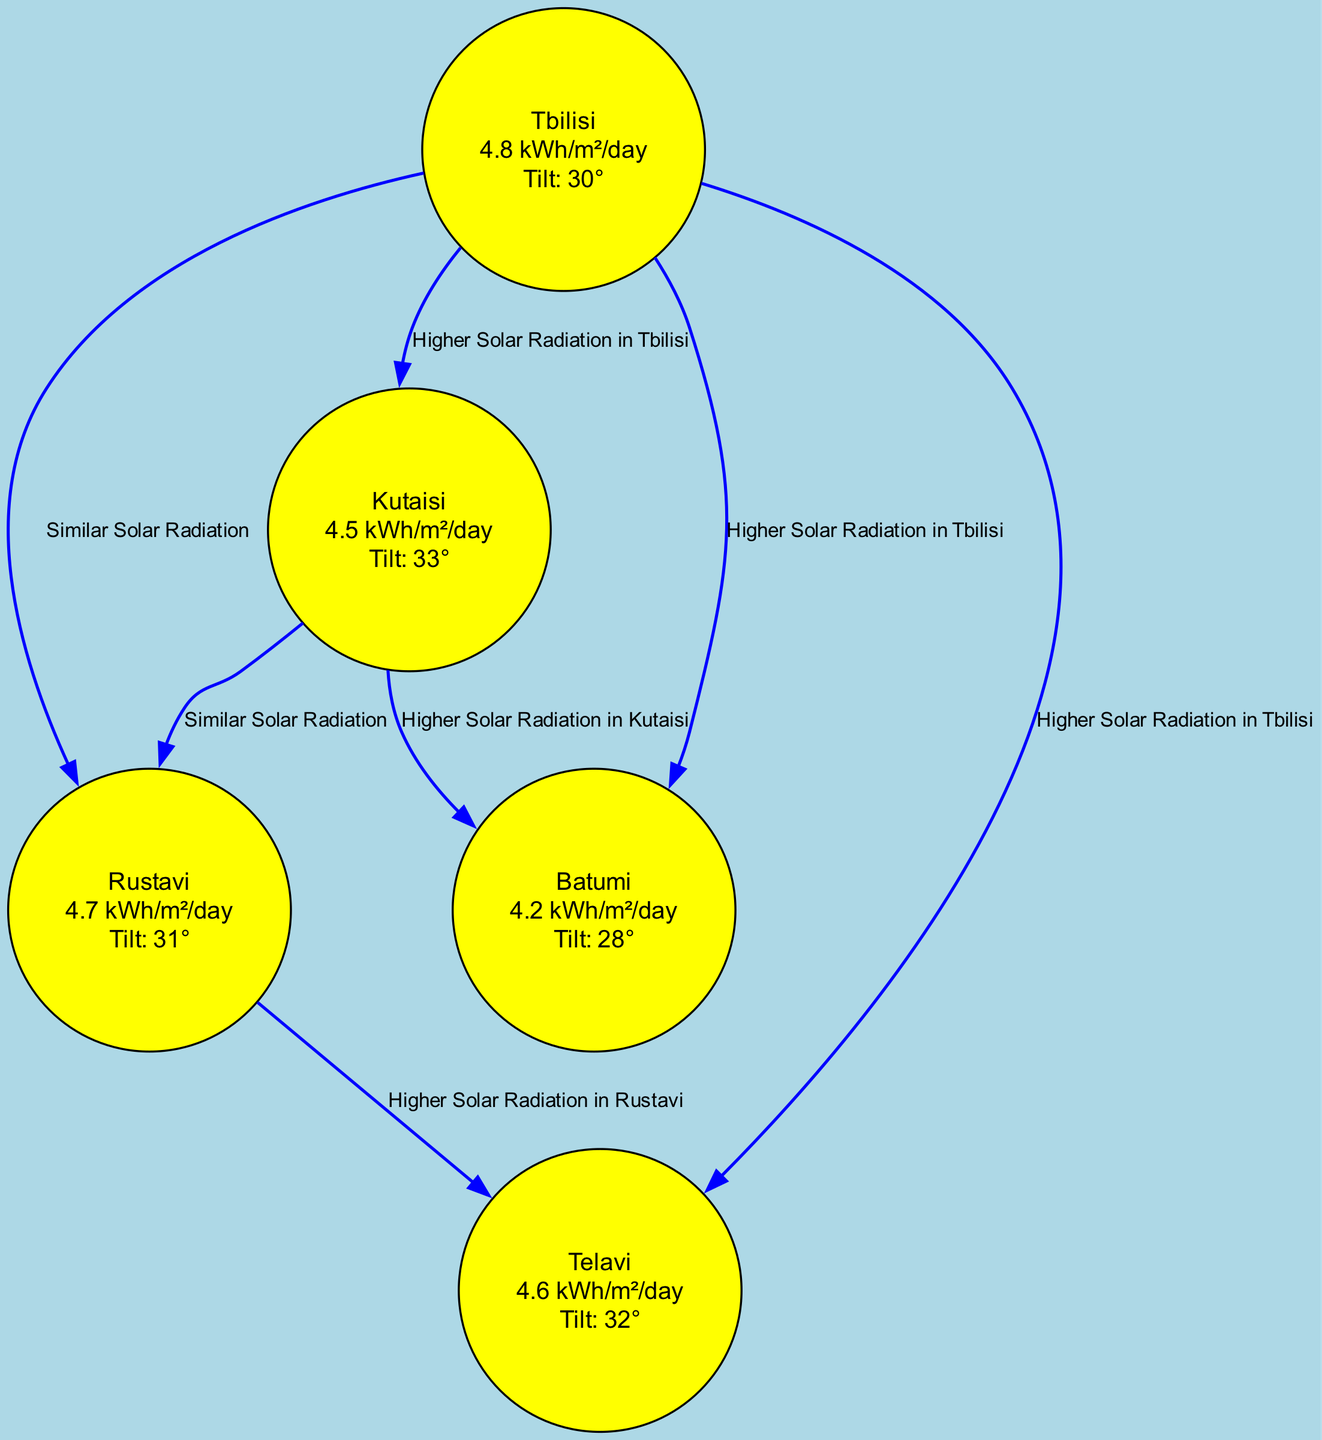What is the average solar radiation in Tbilisi? The diagram shows that Tbilisi has an average solar radiation value listed as "4.8 kWh/m²/day." This information is contained within the node for Tbilisi.
Answer: 4.8 kWh/m²/day What is the optimal tilt angle for solar panels in Batumi? The node for Batumi indicates that the optimal tilt angle is "28°." This detail is specifically provided under Batumi's information in the diagram.
Answer: 28° Which location has higher solar radiation, Tbilisi or Kutaisi? The diagram features an edge labeled "Higher Solar Radiation in Tbilisi" pointing from Tbilisi to Kutaisi. This signifies that Tbilisi has more solar radiation compared to Kutaisi.
Answer: Tbilisi How many nodes are represented in the diagram? The diagram lists five distinct locations (nodes): Tbilisi, Kutaisi, Batumi, Rustavi, and Telavi. Counting these nodes yields a total of five.
Answer: 5 What is the average solar radiation in Rustavi? The node for Rustavi displays an average solar radiation of "4.7 kWh/m²/day," which is clearly stated in its details.
Answer: 4.7 kWh/m²/day Which city has the lowest average solar radiation? By comparing average solar radiation values from all nodes, Batumi has the lowest value of "4.2 kWh/m²/day," making it the city with the least solar radiation in the diagram.
Answer: Batumi How do Tbilisi and Rustavi compare in solar radiation? The diagram shows "Similar Solar Radiation" between Tbilisi and Rustavi with an edge connecting the two. This indicates their solar radiation levels are close and not significantly different.
Answer: Similar Solar Radiation Which location has the optimal tilt angle of 32 degrees? The node for Telavi indicates an optimal tilt angle of "32°," which is specifically mentioned in its details within the diagram.
Answer: Telavi What type of graph is used in this diagram? The diagram is a directed graph, which visually represents the relationships (edges) between the nodes (locations) regarding solar energy potential.
Answer: Directed Graph 